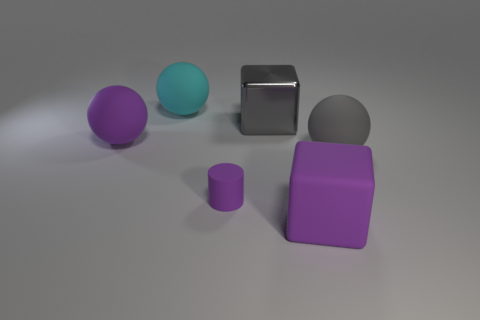The cylinder that is the same material as the cyan object is what color?
Make the answer very short. Purple. How big is the rubber ball on the right side of the tiny purple thing?
Give a very brief answer. Large. Is the material of the gray ball the same as the big gray cube?
Ensure brevity in your answer.  No. Is there a large cyan matte ball behind the ball that is behind the big gray object that is behind the big purple sphere?
Your answer should be compact. No. What is the color of the metallic thing?
Make the answer very short. Gray. There is a rubber block that is the same size as the cyan matte object; what is its color?
Provide a succinct answer. Purple. There is a large purple rubber thing that is left of the small purple cylinder; does it have the same shape as the tiny thing?
Keep it short and to the point. No. There is a block that is to the left of the large block that is in front of the big gray ball in front of the metallic block; what color is it?
Your answer should be very brief. Gray. Are there any purple cylinders?
Offer a terse response. Yes. What number of other things are the same size as the gray shiny object?
Give a very brief answer. 4. 